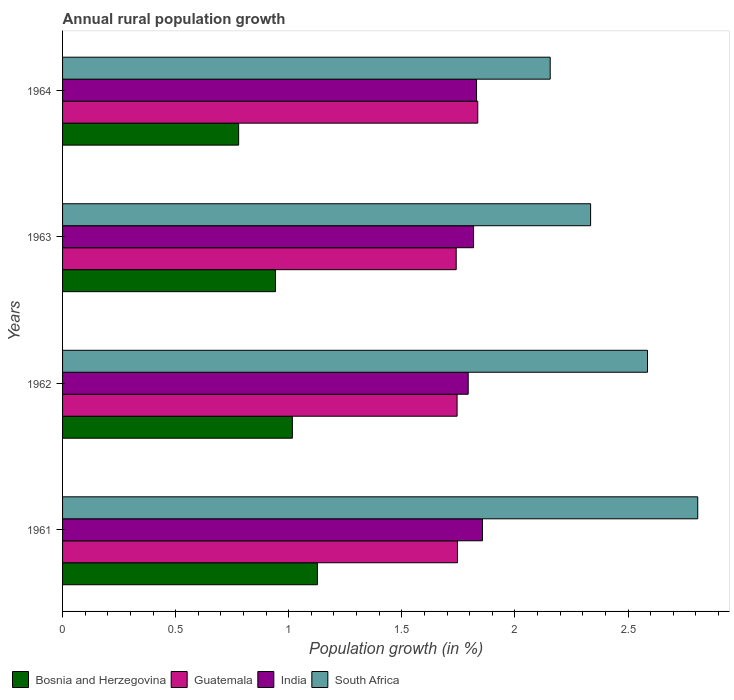Are the number of bars on each tick of the Y-axis equal?
Offer a terse response. Yes. How many bars are there on the 2nd tick from the top?
Your answer should be compact. 4. How many bars are there on the 2nd tick from the bottom?
Offer a very short reply. 4. What is the percentage of rural population growth in Guatemala in 1961?
Offer a terse response. 1.75. Across all years, what is the maximum percentage of rural population growth in Guatemala?
Make the answer very short. 1.84. Across all years, what is the minimum percentage of rural population growth in South Africa?
Provide a succinct answer. 2.16. In which year was the percentage of rural population growth in Bosnia and Herzegovina maximum?
Offer a terse response. 1961. In which year was the percentage of rural population growth in Bosnia and Herzegovina minimum?
Your response must be concise. 1964. What is the total percentage of rural population growth in India in the graph?
Offer a terse response. 7.3. What is the difference between the percentage of rural population growth in India in 1963 and that in 1964?
Your answer should be compact. -0.01. What is the difference between the percentage of rural population growth in South Africa in 1961 and the percentage of rural population growth in Guatemala in 1963?
Make the answer very short. 1.07. What is the average percentage of rural population growth in Guatemala per year?
Give a very brief answer. 1.77. In the year 1964, what is the difference between the percentage of rural population growth in Guatemala and percentage of rural population growth in Bosnia and Herzegovina?
Offer a very short reply. 1.06. What is the ratio of the percentage of rural population growth in India in 1963 to that in 1964?
Give a very brief answer. 0.99. Is the difference between the percentage of rural population growth in Guatemala in 1961 and 1964 greater than the difference between the percentage of rural population growth in Bosnia and Herzegovina in 1961 and 1964?
Your answer should be compact. No. What is the difference between the highest and the second highest percentage of rural population growth in South Africa?
Ensure brevity in your answer.  0.22. What is the difference between the highest and the lowest percentage of rural population growth in India?
Give a very brief answer. 0.06. What does the 4th bar from the top in 1963 represents?
Keep it short and to the point. Bosnia and Herzegovina. What does the 2nd bar from the bottom in 1961 represents?
Ensure brevity in your answer.  Guatemala. Are all the bars in the graph horizontal?
Give a very brief answer. Yes. What is the difference between two consecutive major ticks on the X-axis?
Your response must be concise. 0.5. Are the values on the major ticks of X-axis written in scientific E-notation?
Your response must be concise. No. Does the graph contain any zero values?
Provide a short and direct response. No. Where does the legend appear in the graph?
Your response must be concise. Bottom left. How many legend labels are there?
Provide a short and direct response. 4. What is the title of the graph?
Offer a terse response. Annual rural population growth. Does "Bosnia and Herzegovina" appear as one of the legend labels in the graph?
Your answer should be very brief. Yes. What is the label or title of the X-axis?
Keep it short and to the point. Population growth (in %). What is the Population growth (in %) of Bosnia and Herzegovina in 1961?
Give a very brief answer. 1.13. What is the Population growth (in %) in Guatemala in 1961?
Your answer should be very brief. 1.75. What is the Population growth (in %) in India in 1961?
Provide a short and direct response. 1.86. What is the Population growth (in %) of South Africa in 1961?
Your response must be concise. 2.81. What is the Population growth (in %) of Bosnia and Herzegovina in 1962?
Your answer should be compact. 1.02. What is the Population growth (in %) in Guatemala in 1962?
Keep it short and to the point. 1.74. What is the Population growth (in %) of India in 1962?
Ensure brevity in your answer.  1.79. What is the Population growth (in %) in South Africa in 1962?
Provide a succinct answer. 2.59. What is the Population growth (in %) in Bosnia and Herzegovina in 1963?
Offer a very short reply. 0.94. What is the Population growth (in %) of Guatemala in 1963?
Offer a terse response. 1.74. What is the Population growth (in %) in India in 1963?
Make the answer very short. 1.82. What is the Population growth (in %) in South Africa in 1963?
Your response must be concise. 2.33. What is the Population growth (in %) of Bosnia and Herzegovina in 1964?
Your answer should be compact. 0.78. What is the Population growth (in %) of Guatemala in 1964?
Give a very brief answer. 1.84. What is the Population growth (in %) of India in 1964?
Ensure brevity in your answer.  1.83. What is the Population growth (in %) of South Africa in 1964?
Provide a short and direct response. 2.16. Across all years, what is the maximum Population growth (in %) of Bosnia and Herzegovina?
Keep it short and to the point. 1.13. Across all years, what is the maximum Population growth (in %) of Guatemala?
Ensure brevity in your answer.  1.84. Across all years, what is the maximum Population growth (in %) of India?
Your answer should be very brief. 1.86. Across all years, what is the maximum Population growth (in %) in South Africa?
Keep it short and to the point. 2.81. Across all years, what is the minimum Population growth (in %) of Bosnia and Herzegovina?
Keep it short and to the point. 0.78. Across all years, what is the minimum Population growth (in %) of Guatemala?
Your response must be concise. 1.74. Across all years, what is the minimum Population growth (in %) in India?
Your answer should be compact. 1.79. Across all years, what is the minimum Population growth (in %) in South Africa?
Give a very brief answer. 2.16. What is the total Population growth (in %) of Bosnia and Herzegovina in the graph?
Provide a succinct answer. 3.86. What is the total Population growth (in %) of Guatemala in the graph?
Offer a very short reply. 7.07. What is the total Population growth (in %) of India in the graph?
Offer a terse response. 7.3. What is the total Population growth (in %) in South Africa in the graph?
Provide a succinct answer. 9.89. What is the difference between the Population growth (in %) of Bosnia and Herzegovina in 1961 and that in 1962?
Ensure brevity in your answer.  0.11. What is the difference between the Population growth (in %) of Guatemala in 1961 and that in 1962?
Your answer should be compact. 0. What is the difference between the Population growth (in %) in India in 1961 and that in 1962?
Provide a short and direct response. 0.06. What is the difference between the Population growth (in %) of South Africa in 1961 and that in 1962?
Offer a very short reply. 0.22. What is the difference between the Population growth (in %) in Bosnia and Herzegovina in 1961 and that in 1963?
Make the answer very short. 0.19. What is the difference between the Population growth (in %) of Guatemala in 1961 and that in 1963?
Provide a succinct answer. 0.01. What is the difference between the Population growth (in %) in India in 1961 and that in 1963?
Offer a very short reply. 0.04. What is the difference between the Population growth (in %) of South Africa in 1961 and that in 1963?
Your answer should be very brief. 0.47. What is the difference between the Population growth (in %) in Bosnia and Herzegovina in 1961 and that in 1964?
Provide a succinct answer. 0.35. What is the difference between the Population growth (in %) in Guatemala in 1961 and that in 1964?
Ensure brevity in your answer.  -0.09. What is the difference between the Population growth (in %) of India in 1961 and that in 1964?
Offer a very short reply. 0.03. What is the difference between the Population growth (in %) in South Africa in 1961 and that in 1964?
Provide a succinct answer. 0.65. What is the difference between the Population growth (in %) of Bosnia and Herzegovina in 1962 and that in 1963?
Provide a succinct answer. 0.07. What is the difference between the Population growth (in %) in Guatemala in 1962 and that in 1963?
Your answer should be very brief. 0. What is the difference between the Population growth (in %) in India in 1962 and that in 1963?
Give a very brief answer. -0.02. What is the difference between the Population growth (in %) of South Africa in 1962 and that in 1963?
Give a very brief answer. 0.25. What is the difference between the Population growth (in %) of Bosnia and Herzegovina in 1962 and that in 1964?
Your answer should be very brief. 0.24. What is the difference between the Population growth (in %) of Guatemala in 1962 and that in 1964?
Offer a very short reply. -0.09. What is the difference between the Population growth (in %) in India in 1962 and that in 1964?
Provide a short and direct response. -0.04. What is the difference between the Population growth (in %) of South Africa in 1962 and that in 1964?
Your response must be concise. 0.43. What is the difference between the Population growth (in %) in Bosnia and Herzegovina in 1963 and that in 1964?
Your response must be concise. 0.16. What is the difference between the Population growth (in %) in Guatemala in 1963 and that in 1964?
Your answer should be very brief. -0.1. What is the difference between the Population growth (in %) of India in 1963 and that in 1964?
Offer a terse response. -0.01. What is the difference between the Population growth (in %) in South Africa in 1963 and that in 1964?
Your response must be concise. 0.18. What is the difference between the Population growth (in %) of Bosnia and Herzegovina in 1961 and the Population growth (in %) of Guatemala in 1962?
Keep it short and to the point. -0.62. What is the difference between the Population growth (in %) in Bosnia and Herzegovina in 1961 and the Population growth (in %) in India in 1962?
Offer a terse response. -0.67. What is the difference between the Population growth (in %) of Bosnia and Herzegovina in 1961 and the Population growth (in %) of South Africa in 1962?
Your answer should be compact. -1.46. What is the difference between the Population growth (in %) of Guatemala in 1961 and the Population growth (in %) of India in 1962?
Your response must be concise. -0.05. What is the difference between the Population growth (in %) in Guatemala in 1961 and the Population growth (in %) in South Africa in 1962?
Keep it short and to the point. -0.84. What is the difference between the Population growth (in %) in India in 1961 and the Population growth (in %) in South Africa in 1962?
Offer a terse response. -0.73. What is the difference between the Population growth (in %) in Bosnia and Herzegovina in 1961 and the Population growth (in %) in Guatemala in 1963?
Your answer should be very brief. -0.61. What is the difference between the Population growth (in %) of Bosnia and Herzegovina in 1961 and the Population growth (in %) of India in 1963?
Your answer should be compact. -0.69. What is the difference between the Population growth (in %) in Bosnia and Herzegovina in 1961 and the Population growth (in %) in South Africa in 1963?
Your response must be concise. -1.21. What is the difference between the Population growth (in %) of Guatemala in 1961 and the Population growth (in %) of India in 1963?
Offer a very short reply. -0.07. What is the difference between the Population growth (in %) of Guatemala in 1961 and the Population growth (in %) of South Africa in 1963?
Offer a terse response. -0.59. What is the difference between the Population growth (in %) of India in 1961 and the Population growth (in %) of South Africa in 1963?
Provide a short and direct response. -0.48. What is the difference between the Population growth (in %) in Bosnia and Herzegovina in 1961 and the Population growth (in %) in Guatemala in 1964?
Make the answer very short. -0.71. What is the difference between the Population growth (in %) of Bosnia and Herzegovina in 1961 and the Population growth (in %) of India in 1964?
Offer a terse response. -0.7. What is the difference between the Population growth (in %) in Bosnia and Herzegovina in 1961 and the Population growth (in %) in South Africa in 1964?
Ensure brevity in your answer.  -1.03. What is the difference between the Population growth (in %) of Guatemala in 1961 and the Population growth (in %) of India in 1964?
Offer a terse response. -0.08. What is the difference between the Population growth (in %) of Guatemala in 1961 and the Population growth (in %) of South Africa in 1964?
Give a very brief answer. -0.41. What is the difference between the Population growth (in %) of India in 1961 and the Population growth (in %) of South Africa in 1964?
Offer a terse response. -0.3. What is the difference between the Population growth (in %) in Bosnia and Herzegovina in 1962 and the Population growth (in %) in Guatemala in 1963?
Keep it short and to the point. -0.72. What is the difference between the Population growth (in %) in Bosnia and Herzegovina in 1962 and the Population growth (in %) in India in 1963?
Provide a succinct answer. -0.8. What is the difference between the Population growth (in %) in Bosnia and Herzegovina in 1962 and the Population growth (in %) in South Africa in 1963?
Your answer should be very brief. -1.32. What is the difference between the Population growth (in %) in Guatemala in 1962 and the Population growth (in %) in India in 1963?
Give a very brief answer. -0.07. What is the difference between the Population growth (in %) in Guatemala in 1962 and the Population growth (in %) in South Africa in 1963?
Ensure brevity in your answer.  -0.59. What is the difference between the Population growth (in %) in India in 1962 and the Population growth (in %) in South Africa in 1963?
Keep it short and to the point. -0.54. What is the difference between the Population growth (in %) of Bosnia and Herzegovina in 1962 and the Population growth (in %) of Guatemala in 1964?
Keep it short and to the point. -0.82. What is the difference between the Population growth (in %) of Bosnia and Herzegovina in 1962 and the Population growth (in %) of India in 1964?
Make the answer very short. -0.81. What is the difference between the Population growth (in %) in Bosnia and Herzegovina in 1962 and the Population growth (in %) in South Africa in 1964?
Ensure brevity in your answer.  -1.14. What is the difference between the Population growth (in %) in Guatemala in 1962 and the Population growth (in %) in India in 1964?
Provide a succinct answer. -0.09. What is the difference between the Population growth (in %) of Guatemala in 1962 and the Population growth (in %) of South Africa in 1964?
Make the answer very short. -0.41. What is the difference between the Population growth (in %) of India in 1962 and the Population growth (in %) of South Africa in 1964?
Offer a very short reply. -0.36. What is the difference between the Population growth (in %) of Bosnia and Herzegovina in 1963 and the Population growth (in %) of Guatemala in 1964?
Keep it short and to the point. -0.89. What is the difference between the Population growth (in %) of Bosnia and Herzegovina in 1963 and the Population growth (in %) of India in 1964?
Provide a succinct answer. -0.89. What is the difference between the Population growth (in %) in Bosnia and Herzegovina in 1963 and the Population growth (in %) in South Africa in 1964?
Ensure brevity in your answer.  -1.21. What is the difference between the Population growth (in %) in Guatemala in 1963 and the Population growth (in %) in India in 1964?
Your response must be concise. -0.09. What is the difference between the Population growth (in %) in Guatemala in 1963 and the Population growth (in %) in South Africa in 1964?
Give a very brief answer. -0.42. What is the difference between the Population growth (in %) of India in 1963 and the Population growth (in %) of South Africa in 1964?
Give a very brief answer. -0.34. What is the average Population growth (in %) in Bosnia and Herzegovina per year?
Keep it short and to the point. 0.97. What is the average Population growth (in %) of Guatemala per year?
Offer a very short reply. 1.77. What is the average Population growth (in %) in India per year?
Your response must be concise. 1.82. What is the average Population growth (in %) of South Africa per year?
Give a very brief answer. 2.47. In the year 1961, what is the difference between the Population growth (in %) of Bosnia and Herzegovina and Population growth (in %) of Guatemala?
Provide a succinct answer. -0.62. In the year 1961, what is the difference between the Population growth (in %) of Bosnia and Herzegovina and Population growth (in %) of India?
Your answer should be compact. -0.73. In the year 1961, what is the difference between the Population growth (in %) in Bosnia and Herzegovina and Population growth (in %) in South Africa?
Offer a very short reply. -1.68. In the year 1961, what is the difference between the Population growth (in %) in Guatemala and Population growth (in %) in India?
Give a very brief answer. -0.11. In the year 1961, what is the difference between the Population growth (in %) in Guatemala and Population growth (in %) in South Africa?
Make the answer very short. -1.06. In the year 1961, what is the difference between the Population growth (in %) in India and Population growth (in %) in South Africa?
Offer a terse response. -0.95. In the year 1962, what is the difference between the Population growth (in %) in Bosnia and Herzegovina and Population growth (in %) in Guatemala?
Offer a very short reply. -0.73. In the year 1962, what is the difference between the Population growth (in %) in Bosnia and Herzegovina and Population growth (in %) in India?
Offer a terse response. -0.78. In the year 1962, what is the difference between the Population growth (in %) in Bosnia and Herzegovina and Population growth (in %) in South Africa?
Provide a succinct answer. -1.57. In the year 1962, what is the difference between the Population growth (in %) of Guatemala and Population growth (in %) of India?
Your answer should be very brief. -0.05. In the year 1962, what is the difference between the Population growth (in %) of Guatemala and Population growth (in %) of South Africa?
Provide a short and direct response. -0.84. In the year 1962, what is the difference between the Population growth (in %) in India and Population growth (in %) in South Africa?
Your response must be concise. -0.79. In the year 1963, what is the difference between the Population growth (in %) in Bosnia and Herzegovina and Population growth (in %) in Guatemala?
Offer a terse response. -0.8. In the year 1963, what is the difference between the Population growth (in %) of Bosnia and Herzegovina and Population growth (in %) of India?
Your answer should be compact. -0.88. In the year 1963, what is the difference between the Population growth (in %) of Bosnia and Herzegovina and Population growth (in %) of South Africa?
Make the answer very short. -1.39. In the year 1963, what is the difference between the Population growth (in %) in Guatemala and Population growth (in %) in India?
Give a very brief answer. -0.08. In the year 1963, what is the difference between the Population growth (in %) in Guatemala and Population growth (in %) in South Africa?
Give a very brief answer. -0.59. In the year 1963, what is the difference between the Population growth (in %) of India and Population growth (in %) of South Africa?
Provide a succinct answer. -0.52. In the year 1964, what is the difference between the Population growth (in %) in Bosnia and Herzegovina and Population growth (in %) in Guatemala?
Ensure brevity in your answer.  -1.06. In the year 1964, what is the difference between the Population growth (in %) of Bosnia and Herzegovina and Population growth (in %) of India?
Provide a short and direct response. -1.05. In the year 1964, what is the difference between the Population growth (in %) of Bosnia and Herzegovina and Population growth (in %) of South Africa?
Your answer should be very brief. -1.38. In the year 1964, what is the difference between the Population growth (in %) in Guatemala and Population growth (in %) in India?
Offer a very short reply. 0.01. In the year 1964, what is the difference between the Population growth (in %) of Guatemala and Population growth (in %) of South Africa?
Provide a short and direct response. -0.32. In the year 1964, what is the difference between the Population growth (in %) in India and Population growth (in %) in South Africa?
Offer a very short reply. -0.33. What is the ratio of the Population growth (in %) in Bosnia and Herzegovina in 1961 to that in 1962?
Give a very brief answer. 1.11. What is the ratio of the Population growth (in %) in India in 1961 to that in 1962?
Your response must be concise. 1.04. What is the ratio of the Population growth (in %) in South Africa in 1961 to that in 1962?
Provide a short and direct response. 1.09. What is the ratio of the Population growth (in %) of Bosnia and Herzegovina in 1961 to that in 1963?
Your answer should be very brief. 1.2. What is the ratio of the Population growth (in %) in Guatemala in 1961 to that in 1963?
Your answer should be compact. 1. What is the ratio of the Population growth (in %) of India in 1961 to that in 1963?
Ensure brevity in your answer.  1.02. What is the ratio of the Population growth (in %) in South Africa in 1961 to that in 1963?
Make the answer very short. 1.2. What is the ratio of the Population growth (in %) in Bosnia and Herzegovina in 1961 to that in 1964?
Give a very brief answer. 1.45. What is the ratio of the Population growth (in %) of Guatemala in 1961 to that in 1964?
Keep it short and to the point. 0.95. What is the ratio of the Population growth (in %) in India in 1961 to that in 1964?
Make the answer very short. 1.01. What is the ratio of the Population growth (in %) of South Africa in 1961 to that in 1964?
Your answer should be compact. 1.3. What is the ratio of the Population growth (in %) of Bosnia and Herzegovina in 1962 to that in 1963?
Offer a terse response. 1.08. What is the ratio of the Population growth (in %) in Guatemala in 1962 to that in 1963?
Keep it short and to the point. 1. What is the ratio of the Population growth (in %) in India in 1962 to that in 1963?
Ensure brevity in your answer.  0.99. What is the ratio of the Population growth (in %) of South Africa in 1962 to that in 1963?
Give a very brief answer. 1.11. What is the ratio of the Population growth (in %) in Bosnia and Herzegovina in 1962 to that in 1964?
Keep it short and to the point. 1.3. What is the ratio of the Population growth (in %) in Guatemala in 1962 to that in 1964?
Give a very brief answer. 0.95. What is the ratio of the Population growth (in %) of India in 1962 to that in 1964?
Make the answer very short. 0.98. What is the ratio of the Population growth (in %) of South Africa in 1962 to that in 1964?
Your answer should be compact. 1.2. What is the ratio of the Population growth (in %) in Bosnia and Herzegovina in 1963 to that in 1964?
Provide a short and direct response. 1.21. What is the ratio of the Population growth (in %) of Guatemala in 1963 to that in 1964?
Your response must be concise. 0.95. What is the ratio of the Population growth (in %) of India in 1963 to that in 1964?
Provide a succinct answer. 0.99. What is the ratio of the Population growth (in %) of South Africa in 1963 to that in 1964?
Your answer should be very brief. 1.08. What is the difference between the highest and the second highest Population growth (in %) in Bosnia and Herzegovina?
Ensure brevity in your answer.  0.11. What is the difference between the highest and the second highest Population growth (in %) in Guatemala?
Your answer should be very brief. 0.09. What is the difference between the highest and the second highest Population growth (in %) of India?
Provide a short and direct response. 0.03. What is the difference between the highest and the second highest Population growth (in %) of South Africa?
Provide a succinct answer. 0.22. What is the difference between the highest and the lowest Population growth (in %) of Bosnia and Herzegovina?
Make the answer very short. 0.35. What is the difference between the highest and the lowest Population growth (in %) in Guatemala?
Give a very brief answer. 0.1. What is the difference between the highest and the lowest Population growth (in %) in India?
Keep it short and to the point. 0.06. What is the difference between the highest and the lowest Population growth (in %) in South Africa?
Make the answer very short. 0.65. 